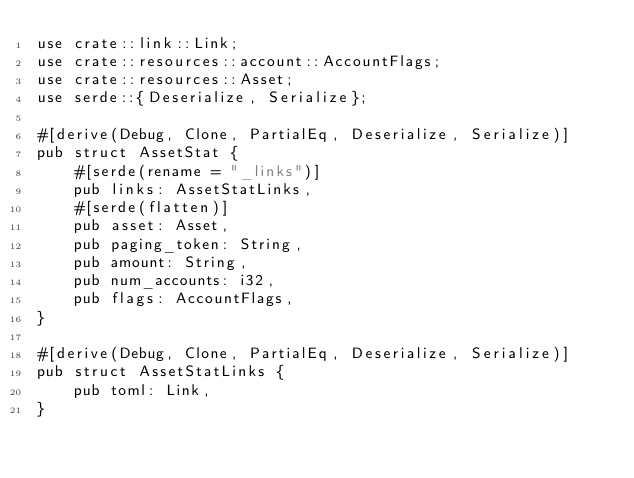<code> <loc_0><loc_0><loc_500><loc_500><_Rust_>use crate::link::Link;
use crate::resources::account::AccountFlags;
use crate::resources::Asset;
use serde::{Deserialize, Serialize};

#[derive(Debug, Clone, PartialEq, Deserialize, Serialize)]
pub struct AssetStat {
    #[serde(rename = "_links")]
    pub links: AssetStatLinks,
    #[serde(flatten)]
    pub asset: Asset,
    pub paging_token: String,
    pub amount: String,
    pub num_accounts: i32,
    pub flags: AccountFlags,
}

#[derive(Debug, Clone, PartialEq, Deserialize, Serialize)]
pub struct AssetStatLinks {
    pub toml: Link,
}
</code> 